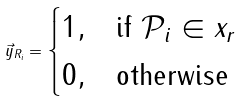<formula> <loc_0><loc_0><loc_500><loc_500>\vec { y } _ { R _ { i } } = \begin{cases} 1 , & \text {if} \ \mathcal { P } _ { i } \in x _ { r } \\ 0 , & \text {otherwise} \end{cases}</formula> 